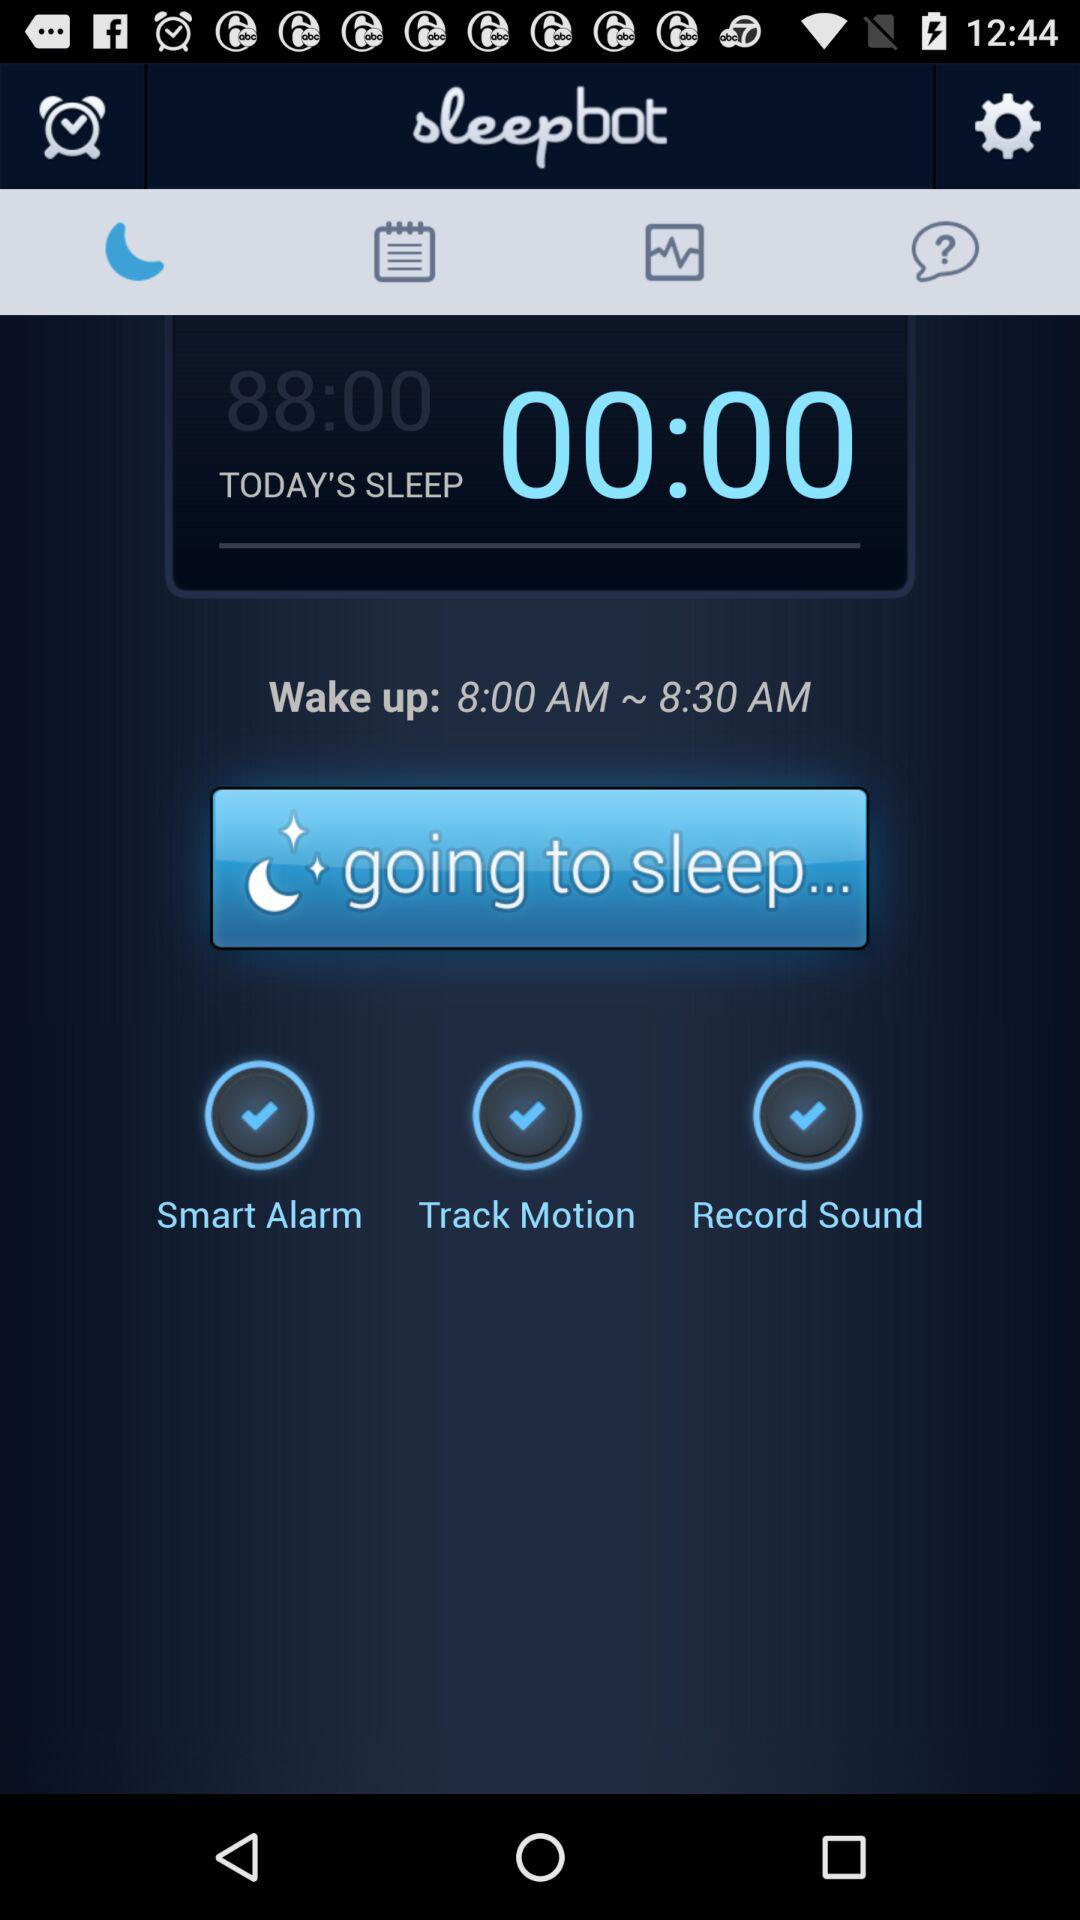How many features are turned on?
Answer the question using a single word or phrase. 3 